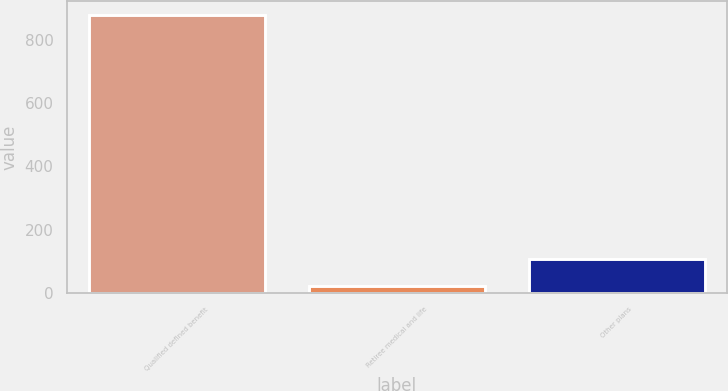Convert chart. <chart><loc_0><loc_0><loc_500><loc_500><bar_chart><fcel>Qualified defined benefit<fcel>Retiree medical and life<fcel>Other plans<nl><fcel>879<fcel>22<fcel>107.7<nl></chart> 